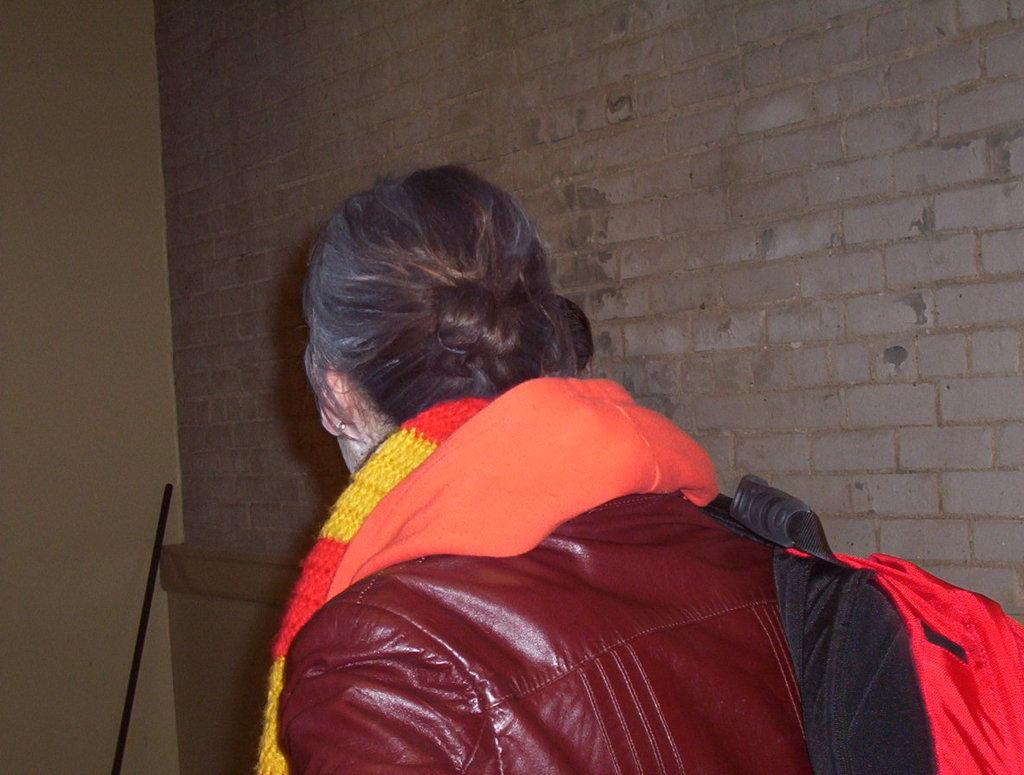What is the main subject of the image? There is a person in the image. What is in front of the person? There is a wall in front of the person. What other object can be seen in the image? There is an iron rod in the image. What grade did the person receive for their invention in the image? There is no mention of an invention or a grade in the image. 